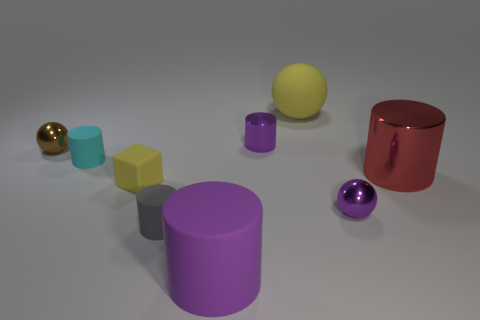What is the color of the sphere that is made of the same material as the brown thing?
Provide a short and direct response. Purple. Is there a brown ball of the same size as the cyan object?
Give a very brief answer. Yes. There is a yellow object that is the same size as the cyan cylinder; what shape is it?
Your answer should be very brief. Cube. Are there any brown metallic things of the same shape as the big yellow thing?
Make the answer very short. Yes. Are the tiny cyan object and the yellow object that is in front of the big yellow ball made of the same material?
Your answer should be very brief. Yes. Are there any blocks of the same color as the big rubber ball?
Your answer should be very brief. Yes. How many other objects are the same material as the small brown ball?
Offer a very short reply. 3. There is a big matte sphere; is it the same color as the matte block that is on the right side of the cyan thing?
Keep it short and to the point. Yes. Are there more shiny spheres to the right of the brown shiny object than large blue shiny objects?
Give a very brief answer. Yes. How many small rubber cubes are behind the purple object to the right of the metal cylinder behind the big red cylinder?
Offer a very short reply. 1. 